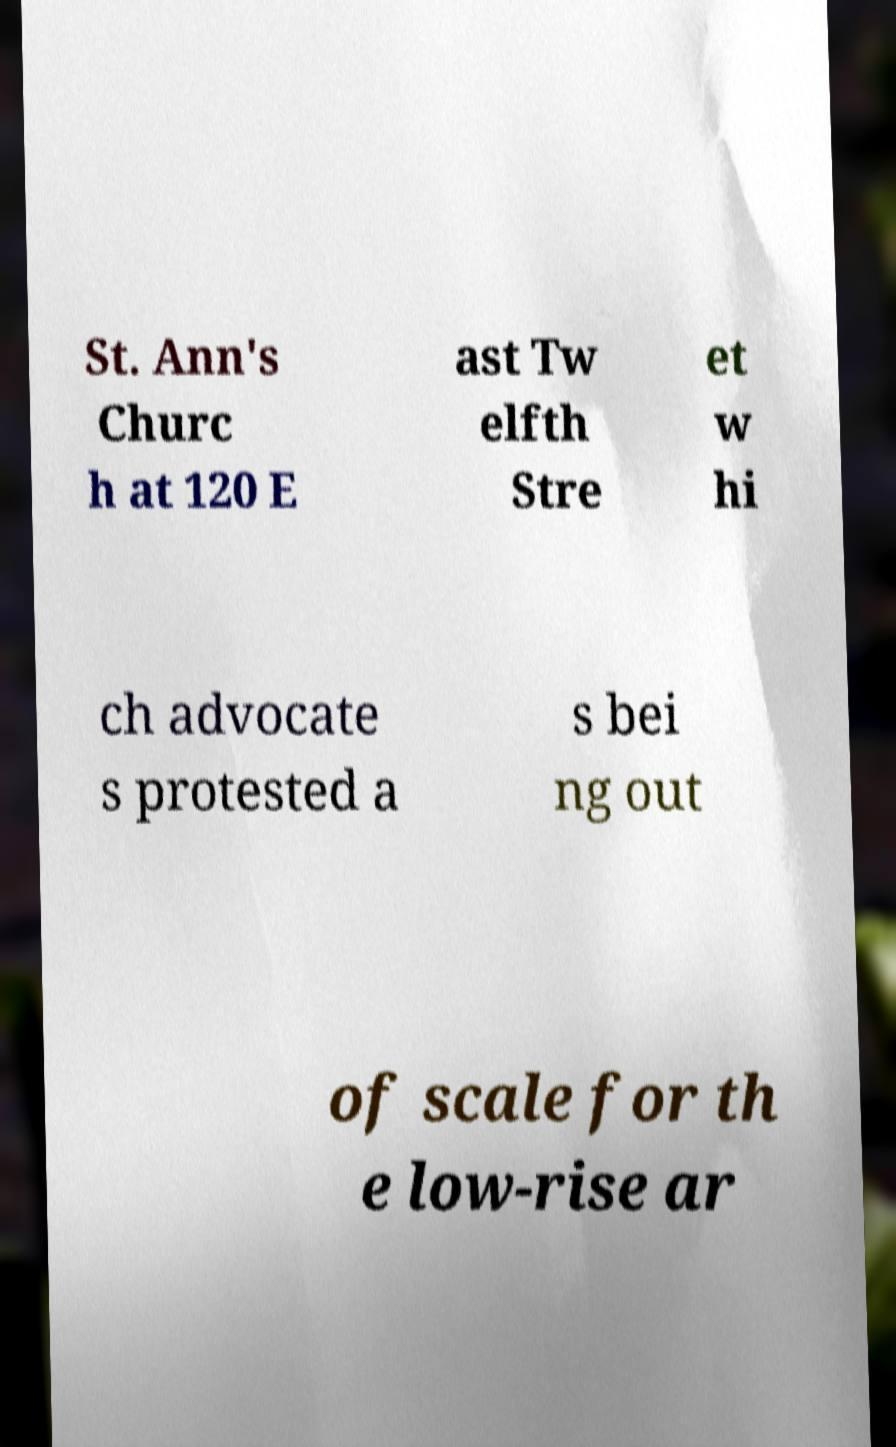Can you read and provide the text displayed in the image?This photo seems to have some interesting text. Can you extract and type it out for me? St. Ann's Churc h at 120 E ast Tw elfth Stre et w hi ch advocate s protested a s bei ng out of scale for th e low-rise ar 